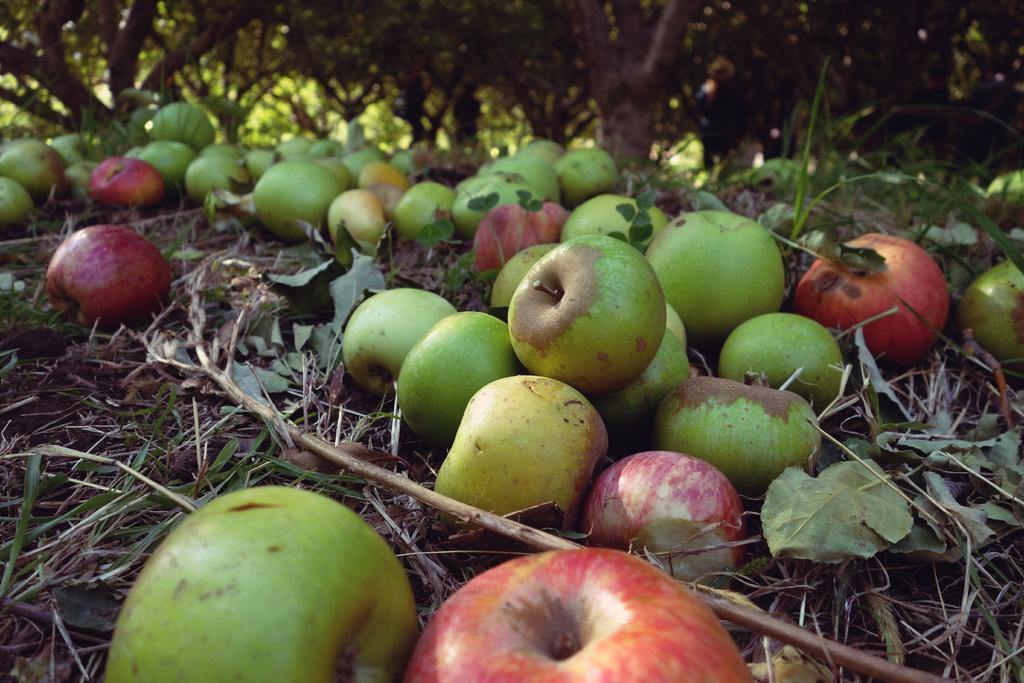What types of apples can be seen in the image? There are red and green color apples in the image. What is visible in the background of the image? There are trees in the background of the image. What type of care is being provided to the bear in the image? There is no bear present in the image, so no care is being provided. What type of land can be seen in the image? The image does not show any specific type of land; it features apples and trees in the background. 